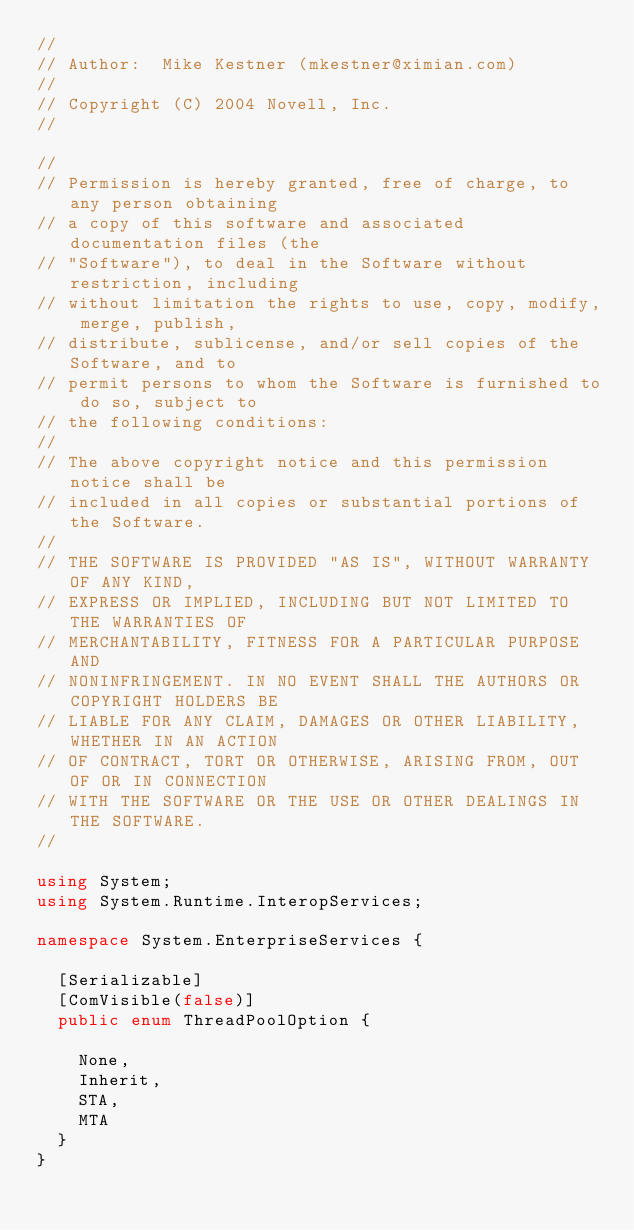<code> <loc_0><loc_0><loc_500><loc_500><_C#_>//
// Author:  Mike Kestner (mkestner@ximian.com)
//
// Copyright (C) 2004 Novell, Inc.
//

//
// Permission is hereby granted, free of charge, to any person obtaining
// a copy of this software and associated documentation files (the
// "Software"), to deal in the Software without restriction, including
// without limitation the rights to use, copy, modify, merge, publish,
// distribute, sublicense, and/or sell copies of the Software, and to
// permit persons to whom the Software is furnished to do so, subject to
// the following conditions:
// 
// The above copyright notice and this permission notice shall be
// included in all copies or substantial portions of the Software.
// 
// THE SOFTWARE IS PROVIDED "AS IS", WITHOUT WARRANTY OF ANY KIND,
// EXPRESS OR IMPLIED, INCLUDING BUT NOT LIMITED TO THE WARRANTIES OF
// MERCHANTABILITY, FITNESS FOR A PARTICULAR PURPOSE AND
// NONINFRINGEMENT. IN NO EVENT SHALL THE AUTHORS OR COPYRIGHT HOLDERS BE
// LIABLE FOR ANY CLAIM, DAMAGES OR OTHER LIABILITY, WHETHER IN AN ACTION
// OF CONTRACT, TORT OR OTHERWISE, ARISING FROM, OUT OF OR IN CONNECTION
// WITH THE SOFTWARE OR THE USE OR OTHER DEALINGS IN THE SOFTWARE.
//

using System;
using System.Runtime.InteropServices;

namespace System.EnterpriseServices {

	[Serializable]
	[ComVisible(false)]
	public enum ThreadPoolOption {

		None,
		Inherit,
		STA,
		MTA
	}
}
</code> 